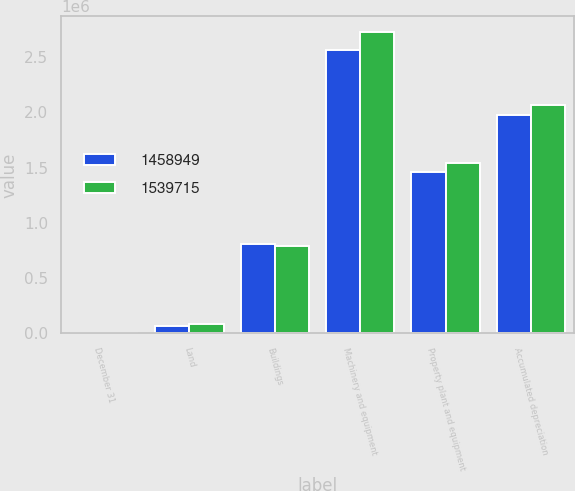Convert chart. <chart><loc_0><loc_0><loc_500><loc_500><stacked_bar_chart><ecel><fcel>December 31<fcel>Land<fcel>Buildings<fcel>Machinery and equipment<fcel>Property plant and equipment<fcel>Accumulated depreciation<nl><fcel>1.45895e+06<fcel>2008<fcel>70226<fcel>805736<fcel>2.56146e+06<fcel>1.45895e+06<fcel>1.97847e+06<nl><fcel>1.53972e+06<fcel>2007<fcel>86596<fcel>788267<fcel>2.73158e+06<fcel>1.53972e+06<fcel>2.06673e+06<nl></chart> 